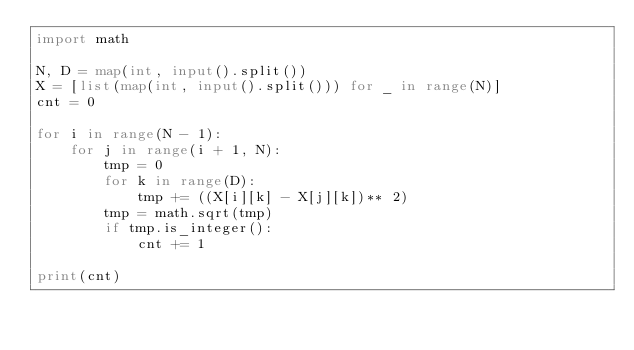<code> <loc_0><loc_0><loc_500><loc_500><_Python_>import math

N, D = map(int, input().split())
X = [list(map(int, input().split())) for _ in range(N)]
cnt = 0

for i in range(N - 1):
    for j in range(i + 1, N):
        tmp = 0
        for k in range(D):
            tmp += ((X[i][k] - X[j][k])** 2)
        tmp = math.sqrt(tmp)
        if tmp.is_integer():
            cnt += 1

print(cnt)
</code> 